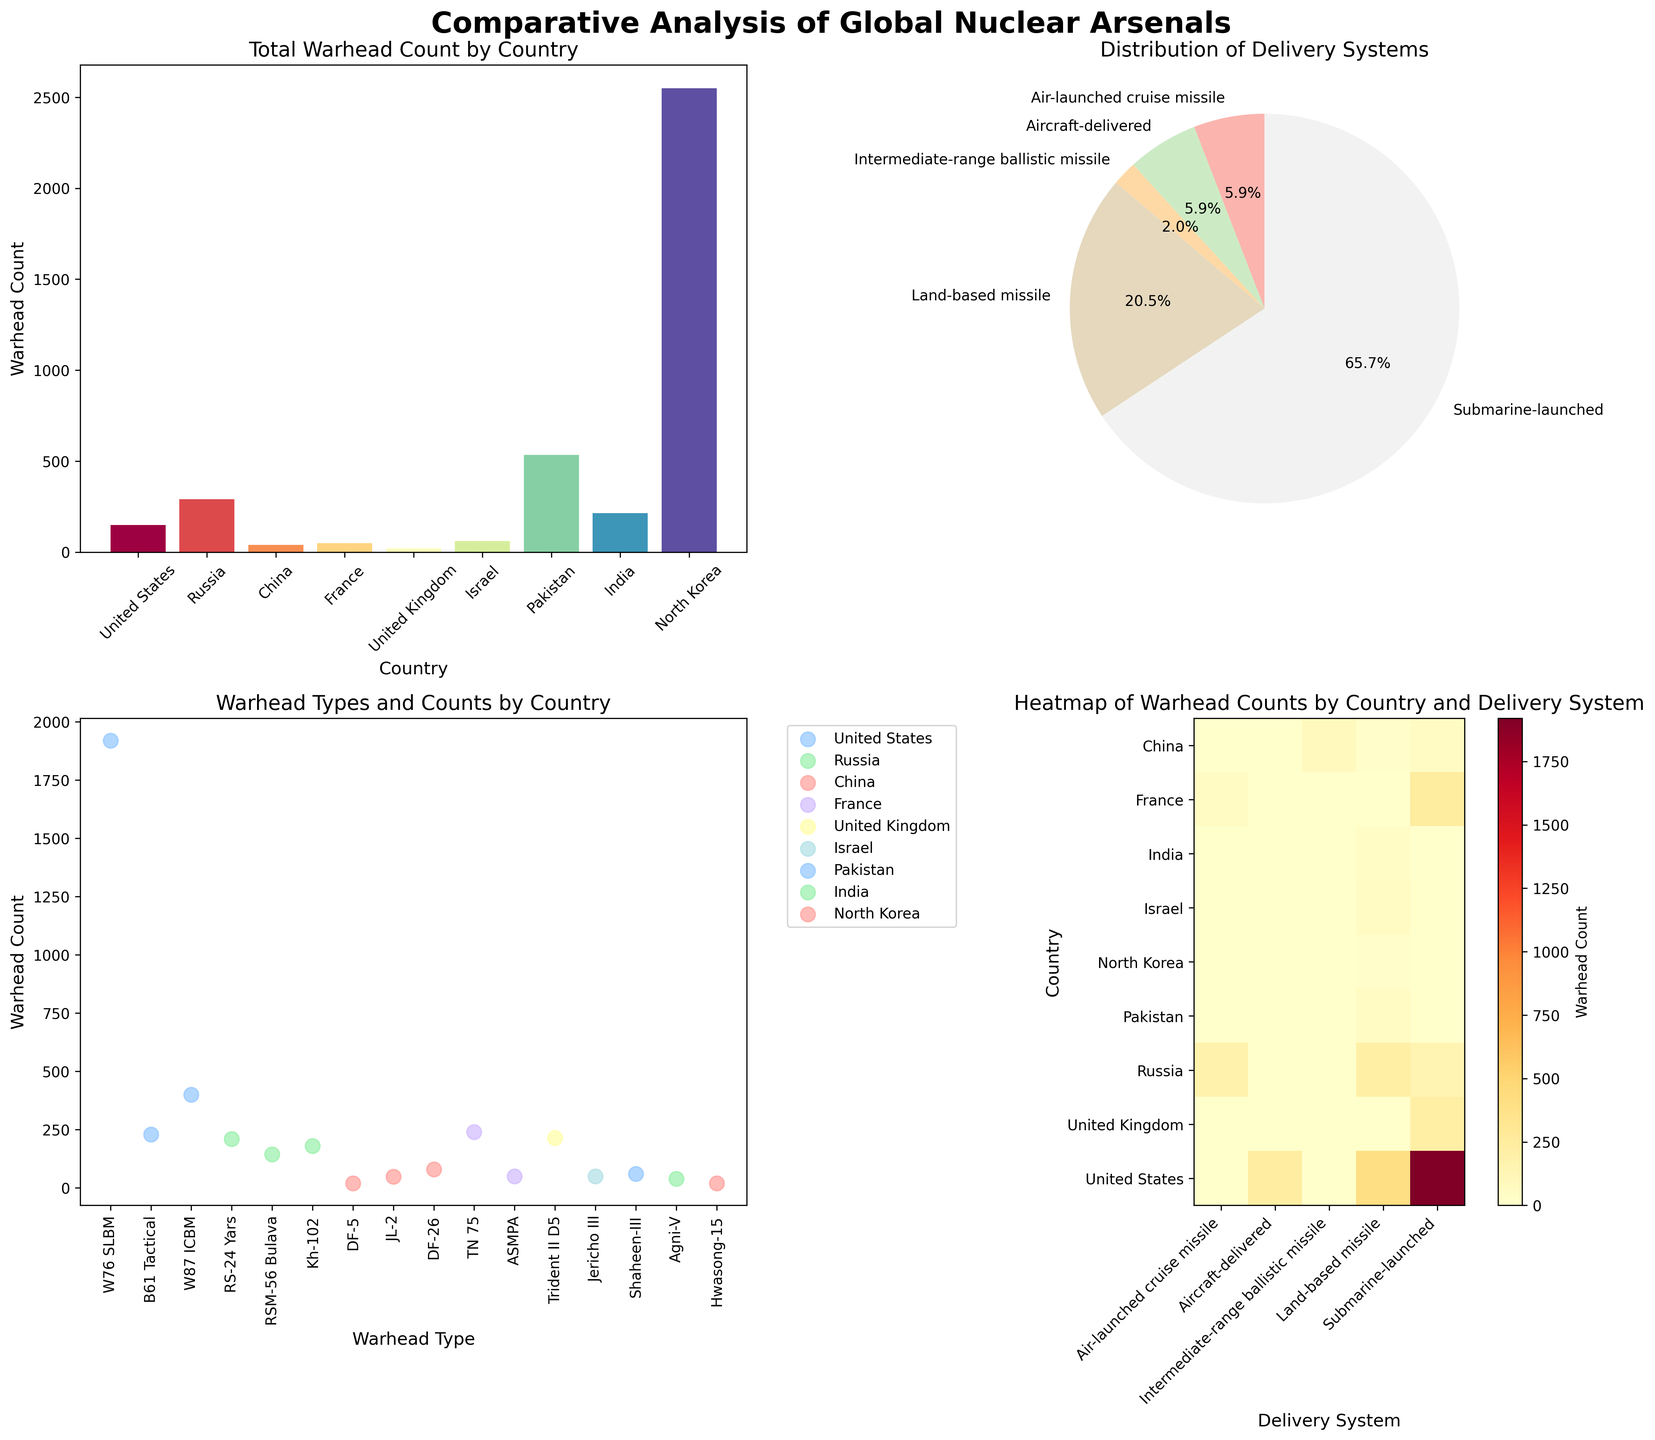What is the title of the bar plot in the top-left corner? The title is located above the bar plot at the top-left corner of the figure. It reads 'Total Warhead Count by Country'.
Answer: Total Warhead Count by Country Which country has the highest total warhead count according to the bar plot? By examining the heights of the bars in the bar plot, the United States has the highest total warhead count.
Answer: United States What percentage of warheads are air-launched cruise missiles according to the pie chart? In the pie chart, the segment labeled 'Air-launched cruise missile' represents this percentage. It is 11.4%.
Answer: 11.4% How many different warhead types are listed for Russia in the scatter plot? In the scatter plot, each warhead type is represented along the x-axis for each country. The warhead types listed for Russia include 'RS-24 Yars', 'RSM-56 Bulava', and 'Kh-102', totaling 3 different types.
Answer: 3 Which delivery system has the highest warhead count in the heatmap? By examining the color intensity in the heatmap, 'Submarine-launched' has the darkest shade, indicating the highest warhead count.
Answer: Submarine-launched Compare the total number of land-based missiles between Russia and China. Which country has more? By examining the bar plot, Russia has 210 land-based missiles (RS-24 Yars) and China has a total of 140 land-based missiles (DF-5 + DF-26).
Answer: Russia What are the x-axis labels of the heatmap in the bottom-right corner? The x-axis labels of the heatmap correspond to the delivery systems and are 'Air-launched cruise missile', 'Aircraft-delivered', 'Intermediate-range ballistic missile', 'Land-based missile', 'Submarine-launched'.
Answer: Air-launched cruise missile, Aircraft-delivered, Intermediate-range ballistic missile, Land-based missile, Submarine-launched What is the total warhead count for the United States according to the bar plot? The bar plot shows a breakdown of warhead counts by country. Summing all warhead counts for the United States: 1920 (W76 SLBM) + 230 (B61 Tactical) + 400 (W87 ICBM) = 2550.
Answer: 2550 Which warhead type has the highest count for China in the scatter plot? By observing the scatter plot, the warhead type 'DF-26' (Intermediate-range ballistic missile) for China has the highest count of 80 warheads.
Answer: DF-26 